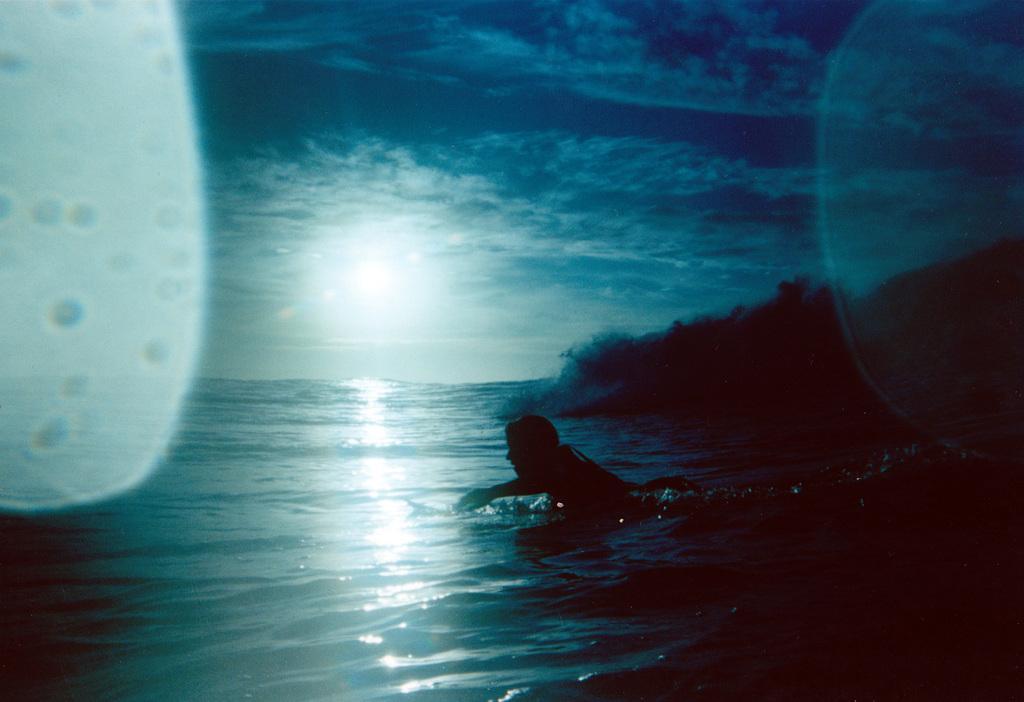How would you summarize this image in a sentence or two? In this image there is a person swimming in the water. Right side there are trees on the land. Top of the image there is sky, having clouds and sun. 